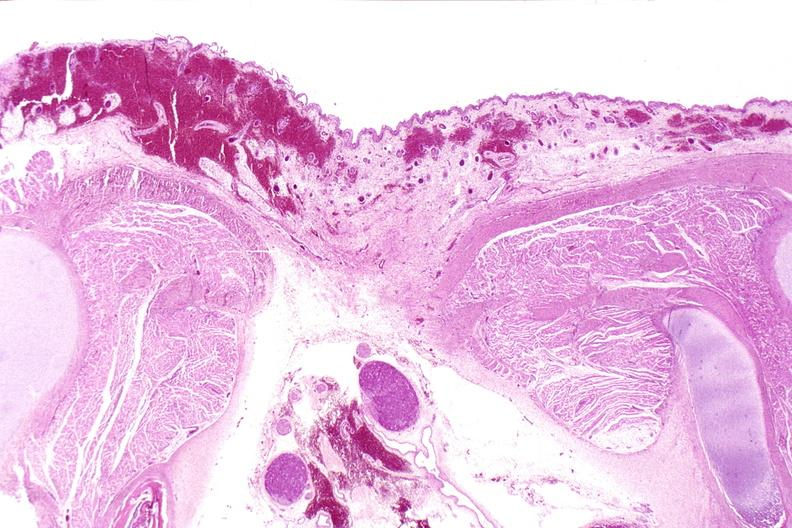where is this?
Answer the question using a single word or phrase. Nervous 